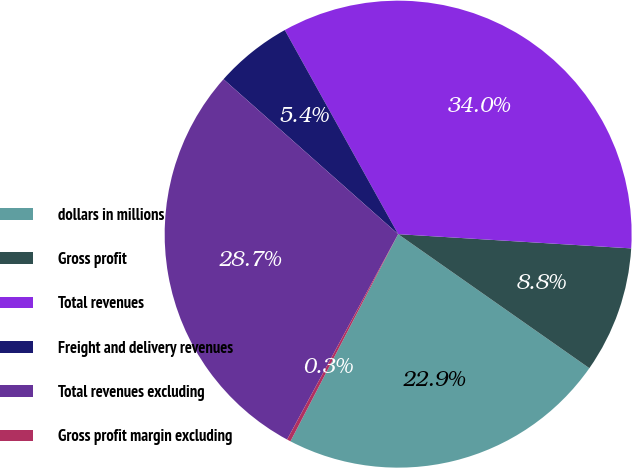Convert chart to OTSL. <chart><loc_0><loc_0><loc_500><loc_500><pie_chart><fcel>dollars in millions<fcel>Gross profit<fcel>Total revenues<fcel>Freight and delivery revenues<fcel>Total revenues excluding<fcel>Gross profit margin excluding<nl><fcel>22.9%<fcel>8.76%<fcel>34.04%<fcel>5.38%<fcel>28.66%<fcel>0.26%<nl></chart> 